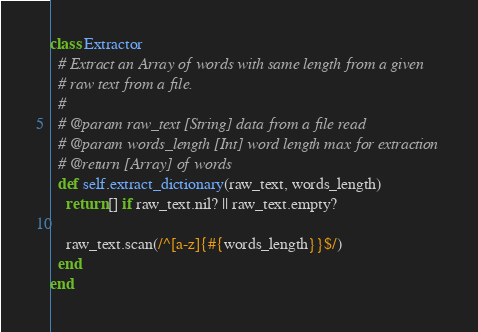<code> <loc_0><loc_0><loc_500><loc_500><_Ruby_>class Extractor
  # Extract an Array of words with same length from a given
  # raw text from a file.
  #
  # @param raw_text [String] data from a file read
  # @param words_length [Int] word length max for extraction
  # @return [Array] of words
  def self.extract_dictionary(raw_text, words_length)
    return [] if raw_text.nil? || raw_text.empty?

    raw_text.scan(/^[a-z]{#{words_length}}$/)
  end
end
</code> 